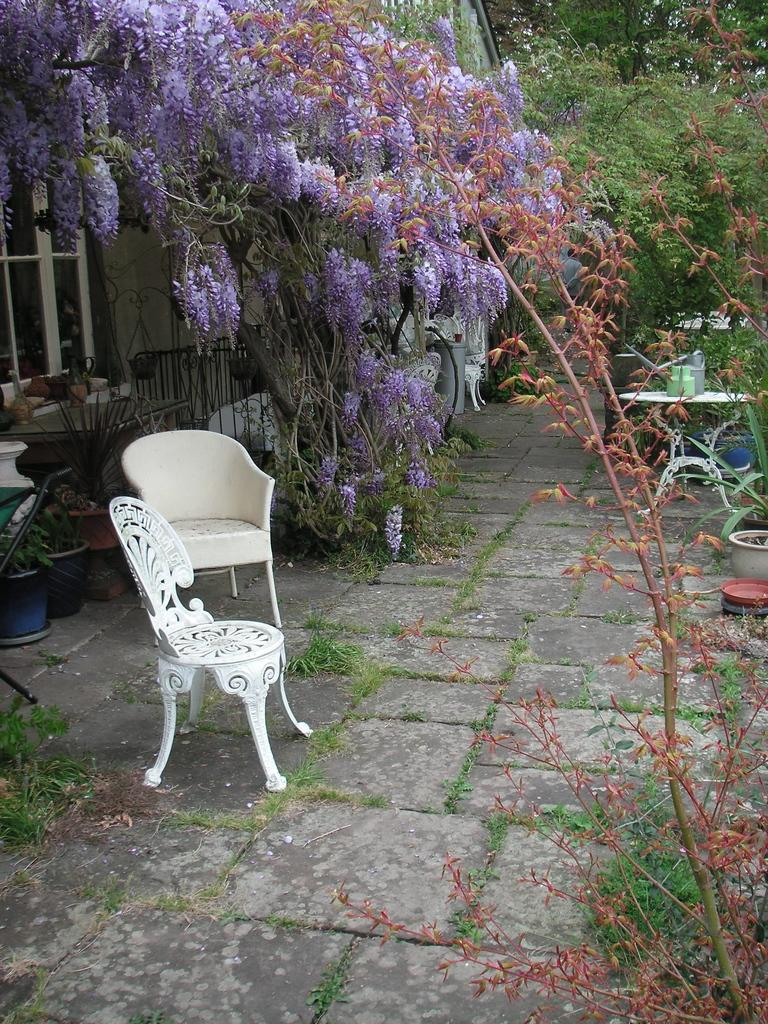What type of furniture is present in the image? There are two white empty chairs in the image. What is located on the table in the image? There is a table with objects on it. What kind of vegetation is visible in the image? There are trees with violet color flowers in the image. What is the shape of the flower pots? The flower pots have heart shapes. Where can you find the rest of the chairs in the image? There are only two white empty chairs present in the image, so there are no additional chairs to find. What type of market is visible in the image? There is no market present in the image; it features chairs, a table, trees, and flower pots. 